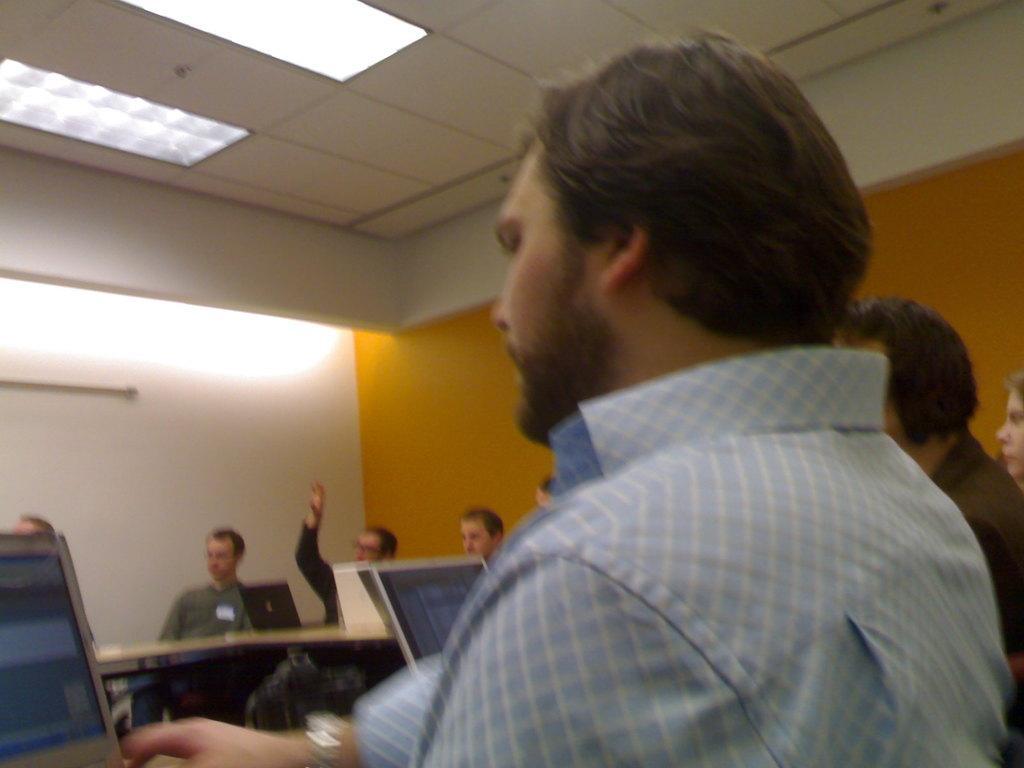How would you summarize this image in a sentence or two? This is an inside view of a room. Here I can see a man sitting and looking into the laptop. In the background I can see some more people sitting in front of the table. On the table there are few laptops. In the background there is a wall and at the top there are few lights. 